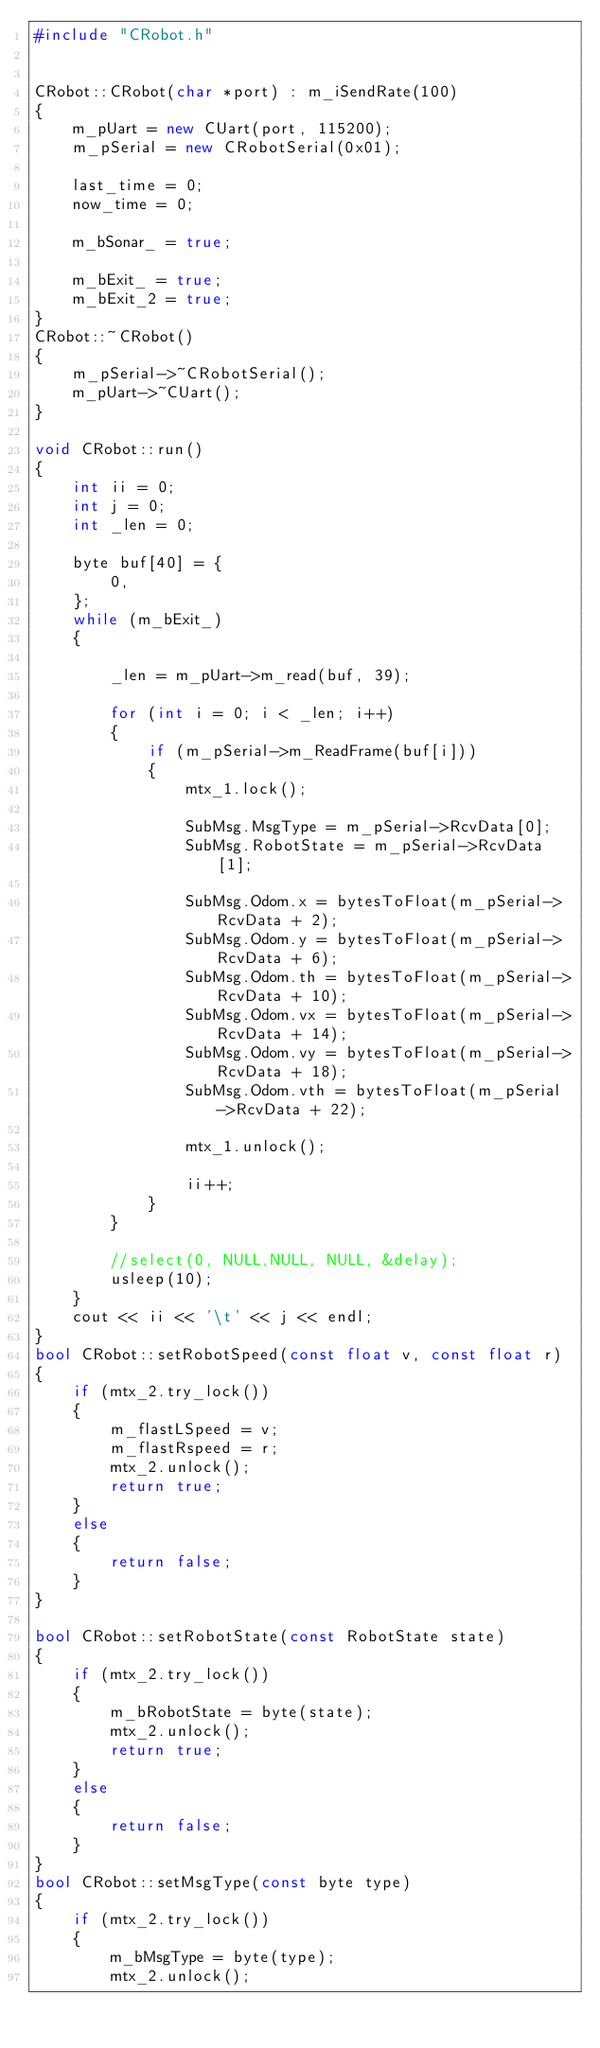<code> <loc_0><loc_0><loc_500><loc_500><_C++_>#include "CRobot.h"


CRobot::CRobot(char *port) : m_iSendRate(100)
{
    m_pUart = new CUart(port, 115200);
    m_pSerial = new CRobotSerial(0x01);

    last_time = 0;
    now_time = 0;

    m_bSonar_ = true;

    m_bExit_ = true;
    m_bExit_2 = true;
}
CRobot::~CRobot()
{
    m_pSerial->~CRobotSerial();
    m_pUart->~CUart();
}

void CRobot::run()
{
    int ii = 0;
    int j = 0;
    int _len = 0;

    byte buf[40] = {
        0,
    };
    while (m_bExit_)
    {
       
        _len = m_pUart->m_read(buf, 39);

        for (int i = 0; i < _len; i++)
        {
            if (m_pSerial->m_ReadFrame(buf[i]))
            {
                mtx_1.lock();

                SubMsg.MsgType = m_pSerial->RcvData[0];
                SubMsg.RobotState = m_pSerial->RcvData[1];

                SubMsg.Odom.x = bytesToFloat(m_pSerial->RcvData + 2);
                SubMsg.Odom.y = bytesToFloat(m_pSerial->RcvData + 6);
                SubMsg.Odom.th = bytesToFloat(m_pSerial->RcvData + 10);
                SubMsg.Odom.vx = bytesToFloat(m_pSerial->RcvData + 14);
                SubMsg.Odom.vy = bytesToFloat(m_pSerial->RcvData + 18);
                SubMsg.Odom.vth = bytesToFloat(m_pSerial->RcvData + 22);

                mtx_1.unlock();

                ii++;
            }
        }

        //select(0, NULL,NULL, NULL, &delay);
        usleep(10);
    }
    cout << ii << '\t' << j << endl;
}
bool CRobot::setRobotSpeed(const float v, const float r)
{
    if (mtx_2.try_lock())
    {
        m_flastLSpeed = v;
        m_flastRspeed = r;
        mtx_2.unlock();
        return true;
    }
    else
    {
        return false;
    }
}

bool CRobot::setRobotState(const RobotState state)
{
    if (mtx_2.try_lock())
    {
        m_bRobotState = byte(state);
        mtx_2.unlock();
        return true;
    }
    else
    {
        return false;
    }
}
bool CRobot::setMsgType(const byte type)
{
    if (mtx_2.try_lock())
    {
        m_bMsgType = byte(type);
        mtx_2.unlock();</code> 